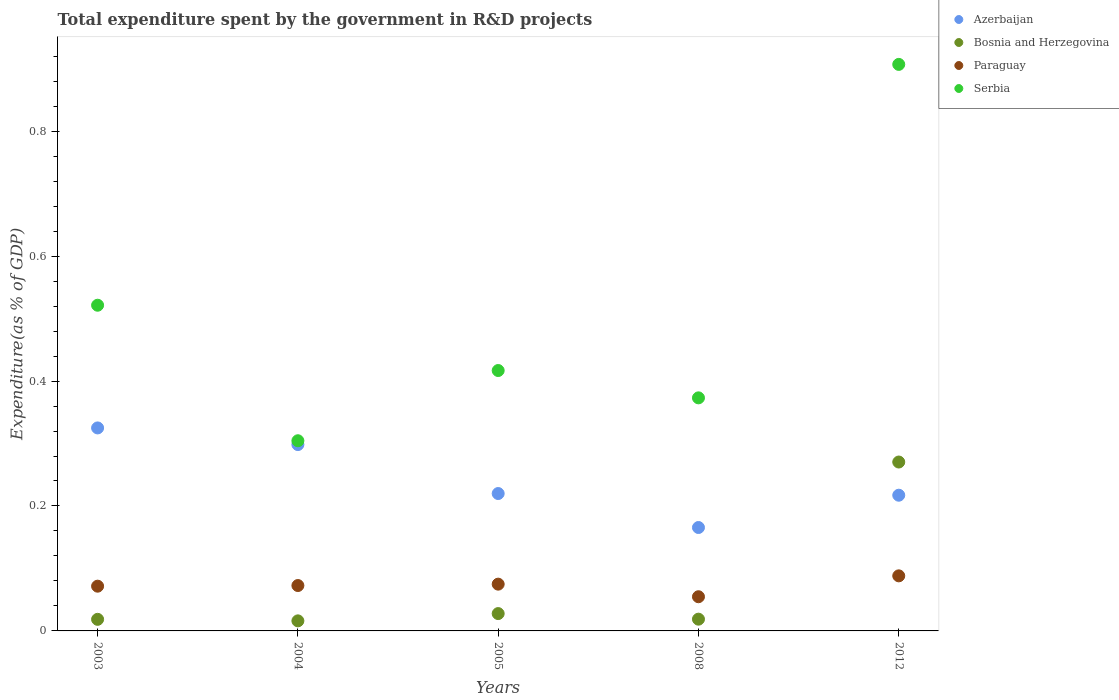How many different coloured dotlines are there?
Offer a terse response. 4. Is the number of dotlines equal to the number of legend labels?
Give a very brief answer. Yes. What is the total expenditure spent by the government in R&D projects in Serbia in 2008?
Give a very brief answer. 0.37. Across all years, what is the maximum total expenditure spent by the government in R&D projects in Paraguay?
Your answer should be very brief. 0.09. Across all years, what is the minimum total expenditure spent by the government in R&D projects in Bosnia and Herzegovina?
Keep it short and to the point. 0.02. In which year was the total expenditure spent by the government in R&D projects in Paraguay maximum?
Keep it short and to the point. 2012. In which year was the total expenditure spent by the government in R&D projects in Serbia minimum?
Provide a short and direct response. 2004. What is the total total expenditure spent by the government in R&D projects in Serbia in the graph?
Make the answer very short. 2.52. What is the difference between the total expenditure spent by the government in R&D projects in Serbia in 2004 and that in 2012?
Offer a very short reply. -0.6. What is the difference between the total expenditure spent by the government in R&D projects in Bosnia and Herzegovina in 2004 and the total expenditure spent by the government in R&D projects in Serbia in 2003?
Your response must be concise. -0.51. What is the average total expenditure spent by the government in R&D projects in Paraguay per year?
Provide a short and direct response. 0.07. In the year 2008, what is the difference between the total expenditure spent by the government in R&D projects in Serbia and total expenditure spent by the government in R&D projects in Paraguay?
Provide a short and direct response. 0.32. What is the ratio of the total expenditure spent by the government in R&D projects in Serbia in 2004 to that in 2008?
Provide a succinct answer. 0.82. Is the total expenditure spent by the government in R&D projects in Paraguay in 2003 less than that in 2008?
Provide a succinct answer. No. What is the difference between the highest and the second highest total expenditure spent by the government in R&D projects in Paraguay?
Offer a very short reply. 0.01. What is the difference between the highest and the lowest total expenditure spent by the government in R&D projects in Serbia?
Your response must be concise. 0.6. In how many years, is the total expenditure spent by the government in R&D projects in Serbia greater than the average total expenditure spent by the government in R&D projects in Serbia taken over all years?
Give a very brief answer. 2. Is it the case that in every year, the sum of the total expenditure spent by the government in R&D projects in Bosnia and Herzegovina and total expenditure spent by the government in R&D projects in Paraguay  is greater than the sum of total expenditure spent by the government in R&D projects in Azerbaijan and total expenditure spent by the government in R&D projects in Serbia?
Your answer should be compact. No. Is it the case that in every year, the sum of the total expenditure spent by the government in R&D projects in Azerbaijan and total expenditure spent by the government in R&D projects in Serbia  is greater than the total expenditure spent by the government in R&D projects in Bosnia and Herzegovina?
Provide a short and direct response. Yes. How many dotlines are there?
Give a very brief answer. 4. How many legend labels are there?
Provide a succinct answer. 4. What is the title of the graph?
Make the answer very short. Total expenditure spent by the government in R&D projects. What is the label or title of the Y-axis?
Your answer should be compact. Expenditure(as % of GDP). What is the Expenditure(as % of GDP) of Azerbaijan in 2003?
Your response must be concise. 0.32. What is the Expenditure(as % of GDP) in Bosnia and Herzegovina in 2003?
Your answer should be very brief. 0.02. What is the Expenditure(as % of GDP) in Paraguay in 2003?
Your answer should be compact. 0.07. What is the Expenditure(as % of GDP) of Serbia in 2003?
Give a very brief answer. 0.52. What is the Expenditure(as % of GDP) of Azerbaijan in 2004?
Make the answer very short. 0.3. What is the Expenditure(as % of GDP) of Bosnia and Herzegovina in 2004?
Offer a terse response. 0.02. What is the Expenditure(as % of GDP) of Paraguay in 2004?
Offer a terse response. 0.07. What is the Expenditure(as % of GDP) in Serbia in 2004?
Offer a terse response. 0.3. What is the Expenditure(as % of GDP) in Azerbaijan in 2005?
Your answer should be compact. 0.22. What is the Expenditure(as % of GDP) in Bosnia and Herzegovina in 2005?
Your answer should be compact. 0.03. What is the Expenditure(as % of GDP) in Paraguay in 2005?
Your answer should be very brief. 0.07. What is the Expenditure(as % of GDP) of Serbia in 2005?
Offer a very short reply. 0.42. What is the Expenditure(as % of GDP) in Azerbaijan in 2008?
Offer a very short reply. 0.17. What is the Expenditure(as % of GDP) in Bosnia and Herzegovina in 2008?
Provide a succinct answer. 0.02. What is the Expenditure(as % of GDP) of Paraguay in 2008?
Provide a succinct answer. 0.05. What is the Expenditure(as % of GDP) of Serbia in 2008?
Make the answer very short. 0.37. What is the Expenditure(as % of GDP) in Azerbaijan in 2012?
Offer a very short reply. 0.22. What is the Expenditure(as % of GDP) in Bosnia and Herzegovina in 2012?
Your answer should be compact. 0.27. What is the Expenditure(as % of GDP) of Paraguay in 2012?
Make the answer very short. 0.09. What is the Expenditure(as % of GDP) of Serbia in 2012?
Offer a very short reply. 0.91. Across all years, what is the maximum Expenditure(as % of GDP) in Azerbaijan?
Offer a terse response. 0.32. Across all years, what is the maximum Expenditure(as % of GDP) of Bosnia and Herzegovina?
Provide a succinct answer. 0.27. Across all years, what is the maximum Expenditure(as % of GDP) in Paraguay?
Provide a succinct answer. 0.09. Across all years, what is the maximum Expenditure(as % of GDP) of Serbia?
Give a very brief answer. 0.91. Across all years, what is the minimum Expenditure(as % of GDP) of Azerbaijan?
Ensure brevity in your answer.  0.17. Across all years, what is the minimum Expenditure(as % of GDP) in Bosnia and Herzegovina?
Ensure brevity in your answer.  0.02. Across all years, what is the minimum Expenditure(as % of GDP) in Paraguay?
Your answer should be compact. 0.05. Across all years, what is the minimum Expenditure(as % of GDP) of Serbia?
Your response must be concise. 0.3. What is the total Expenditure(as % of GDP) in Azerbaijan in the graph?
Your answer should be compact. 1.23. What is the total Expenditure(as % of GDP) of Bosnia and Herzegovina in the graph?
Offer a terse response. 0.35. What is the total Expenditure(as % of GDP) in Paraguay in the graph?
Provide a short and direct response. 0.36. What is the total Expenditure(as % of GDP) of Serbia in the graph?
Your answer should be compact. 2.52. What is the difference between the Expenditure(as % of GDP) of Azerbaijan in 2003 and that in 2004?
Provide a succinct answer. 0.03. What is the difference between the Expenditure(as % of GDP) of Bosnia and Herzegovina in 2003 and that in 2004?
Give a very brief answer. 0. What is the difference between the Expenditure(as % of GDP) of Paraguay in 2003 and that in 2004?
Ensure brevity in your answer.  -0. What is the difference between the Expenditure(as % of GDP) of Serbia in 2003 and that in 2004?
Give a very brief answer. 0.22. What is the difference between the Expenditure(as % of GDP) of Azerbaijan in 2003 and that in 2005?
Ensure brevity in your answer.  0.1. What is the difference between the Expenditure(as % of GDP) of Bosnia and Herzegovina in 2003 and that in 2005?
Your answer should be very brief. -0.01. What is the difference between the Expenditure(as % of GDP) of Paraguay in 2003 and that in 2005?
Offer a terse response. -0. What is the difference between the Expenditure(as % of GDP) in Serbia in 2003 and that in 2005?
Make the answer very short. 0.1. What is the difference between the Expenditure(as % of GDP) in Azerbaijan in 2003 and that in 2008?
Give a very brief answer. 0.16. What is the difference between the Expenditure(as % of GDP) of Bosnia and Herzegovina in 2003 and that in 2008?
Give a very brief answer. -0. What is the difference between the Expenditure(as % of GDP) in Paraguay in 2003 and that in 2008?
Keep it short and to the point. 0.02. What is the difference between the Expenditure(as % of GDP) of Serbia in 2003 and that in 2008?
Offer a terse response. 0.15. What is the difference between the Expenditure(as % of GDP) of Azerbaijan in 2003 and that in 2012?
Your response must be concise. 0.11. What is the difference between the Expenditure(as % of GDP) of Bosnia and Herzegovina in 2003 and that in 2012?
Give a very brief answer. -0.25. What is the difference between the Expenditure(as % of GDP) in Paraguay in 2003 and that in 2012?
Your answer should be compact. -0.02. What is the difference between the Expenditure(as % of GDP) in Serbia in 2003 and that in 2012?
Give a very brief answer. -0.39. What is the difference between the Expenditure(as % of GDP) in Azerbaijan in 2004 and that in 2005?
Give a very brief answer. 0.08. What is the difference between the Expenditure(as % of GDP) of Bosnia and Herzegovina in 2004 and that in 2005?
Your answer should be very brief. -0.01. What is the difference between the Expenditure(as % of GDP) in Paraguay in 2004 and that in 2005?
Your response must be concise. -0. What is the difference between the Expenditure(as % of GDP) in Serbia in 2004 and that in 2005?
Your answer should be compact. -0.11. What is the difference between the Expenditure(as % of GDP) in Azerbaijan in 2004 and that in 2008?
Offer a terse response. 0.13. What is the difference between the Expenditure(as % of GDP) in Bosnia and Herzegovina in 2004 and that in 2008?
Make the answer very short. -0. What is the difference between the Expenditure(as % of GDP) in Paraguay in 2004 and that in 2008?
Provide a succinct answer. 0.02. What is the difference between the Expenditure(as % of GDP) of Serbia in 2004 and that in 2008?
Offer a very short reply. -0.07. What is the difference between the Expenditure(as % of GDP) of Azerbaijan in 2004 and that in 2012?
Offer a very short reply. 0.08. What is the difference between the Expenditure(as % of GDP) in Bosnia and Herzegovina in 2004 and that in 2012?
Ensure brevity in your answer.  -0.25. What is the difference between the Expenditure(as % of GDP) of Paraguay in 2004 and that in 2012?
Provide a short and direct response. -0.02. What is the difference between the Expenditure(as % of GDP) in Serbia in 2004 and that in 2012?
Provide a succinct answer. -0.6. What is the difference between the Expenditure(as % of GDP) in Azerbaijan in 2005 and that in 2008?
Keep it short and to the point. 0.05. What is the difference between the Expenditure(as % of GDP) of Bosnia and Herzegovina in 2005 and that in 2008?
Your response must be concise. 0.01. What is the difference between the Expenditure(as % of GDP) in Paraguay in 2005 and that in 2008?
Your answer should be compact. 0.02. What is the difference between the Expenditure(as % of GDP) of Serbia in 2005 and that in 2008?
Provide a succinct answer. 0.04. What is the difference between the Expenditure(as % of GDP) in Azerbaijan in 2005 and that in 2012?
Give a very brief answer. 0. What is the difference between the Expenditure(as % of GDP) of Bosnia and Herzegovina in 2005 and that in 2012?
Make the answer very short. -0.24. What is the difference between the Expenditure(as % of GDP) in Paraguay in 2005 and that in 2012?
Your response must be concise. -0.01. What is the difference between the Expenditure(as % of GDP) in Serbia in 2005 and that in 2012?
Offer a very short reply. -0.49. What is the difference between the Expenditure(as % of GDP) in Azerbaijan in 2008 and that in 2012?
Your response must be concise. -0.05. What is the difference between the Expenditure(as % of GDP) in Bosnia and Herzegovina in 2008 and that in 2012?
Your answer should be compact. -0.25. What is the difference between the Expenditure(as % of GDP) of Paraguay in 2008 and that in 2012?
Provide a short and direct response. -0.03. What is the difference between the Expenditure(as % of GDP) of Serbia in 2008 and that in 2012?
Your answer should be very brief. -0.53. What is the difference between the Expenditure(as % of GDP) in Azerbaijan in 2003 and the Expenditure(as % of GDP) in Bosnia and Herzegovina in 2004?
Make the answer very short. 0.31. What is the difference between the Expenditure(as % of GDP) of Azerbaijan in 2003 and the Expenditure(as % of GDP) of Paraguay in 2004?
Ensure brevity in your answer.  0.25. What is the difference between the Expenditure(as % of GDP) of Azerbaijan in 2003 and the Expenditure(as % of GDP) of Serbia in 2004?
Give a very brief answer. 0.02. What is the difference between the Expenditure(as % of GDP) in Bosnia and Herzegovina in 2003 and the Expenditure(as % of GDP) in Paraguay in 2004?
Keep it short and to the point. -0.05. What is the difference between the Expenditure(as % of GDP) in Bosnia and Herzegovina in 2003 and the Expenditure(as % of GDP) in Serbia in 2004?
Provide a succinct answer. -0.29. What is the difference between the Expenditure(as % of GDP) of Paraguay in 2003 and the Expenditure(as % of GDP) of Serbia in 2004?
Your response must be concise. -0.23. What is the difference between the Expenditure(as % of GDP) of Azerbaijan in 2003 and the Expenditure(as % of GDP) of Bosnia and Herzegovina in 2005?
Give a very brief answer. 0.3. What is the difference between the Expenditure(as % of GDP) of Azerbaijan in 2003 and the Expenditure(as % of GDP) of Paraguay in 2005?
Keep it short and to the point. 0.25. What is the difference between the Expenditure(as % of GDP) of Azerbaijan in 2003 and the Expenditure(as % of GDP) of Serbia in 2005?
Provide a succinct answer. -0.09. What is the difference between the Expenditure(as % of GDP) in Bosnia and Herzegovina in 2003 and the Expenditure(as % of GDP) in Paraguay in 2005?
Keep it short and to the point. -0.06. What is the difference between the Expenditure(as % of GDP) of Bosnia and Herzegovina in 2003 and the Expenditure(as % of GDP) of Serbia in 2005?
Your answer should be very brief. -0.4. What is the difference between the Expenditure(as % of GDP) of Paraguay in 2003 and the Expenditure(as % of GDP) of Serbia in 2005?
Your answer should be compact. -0.35. What is the difference between the Expenditure(as % of GDP) in Azerbaijan in 2003 and the Expenditure(as % of GDP) in Bosnia and Herzegovina in 2008?
Keep it short and to the point. 0.31. What is the difference between the Expenditure(as % of GDP) in Azerbaijan in 2003 and the Expenditure(as % of GDP) in Paraguay in 2008?
Your answer should be compact. 0.27. What is the difference between the Expenditure(as % of GDP) in Azerbaijan in 2003 and the Expenditure(as % of GDP) in Serbia in 2008?
Give a very brief answer. -0.05. What is the difference between the Expenditure(as % of GDP) in Bosnia and Herzegovina in 2003 and the Expenditure(as % of GDP) in Paraguay in 2008?
Offer a very short reply. -0.04. What is the difference between the Expenditure(as % of GDP) in Bosnia and Herzegovina in 2003 and the Expenditure(as % of GDP) in Serbia in 2008?
Your answer should be very brief. -0.35. What is the difference between the Expenditure(as % of GDP) of Paraguay in 2003 and the Expenditure(as % of GDP) of Serbia in 2008?
Offer a very short reply. -0.3. What is the difference between the Expenditure(as % of GDP) of Azerbaijan in 2003 and the Expenditure(as % of GDP) of Bosnia and Herzegovina in 2012?
Offer a very short reply. 0.05. What is the difference between the Expenditure(as % of GDP) in Azerbaijan in 2003 and the Expenditure(as % of GDP) in Paraguay in 2012?
Your answer should be very brief. 0.24. What is the difference between the Expenditure(as % of GDP) in Azerbaijan in 2003 and the Expenditure(as % of GDP) in Serbia in 2012?
Keep it short and to the point. -0.58. What is the difference between the Expenditure(as % of GDP) of Bosnia and Herzegovina in 2003 and the Expenditure(as % of GDP) of Paraguay in 2012?
Offer a very short reply. -0.07. What is the difference between the Expenditure(as % of GDP) of Bosnia and Herzegovina in 2003 and the Expenditure(as % of GDP) of Serbia in 2012?
Give a very brief answer. -0.89. What is the difference between the Expenditure(as % of GDP) in Paraguay in 2003 and the Expenditure(as % of GDP) in Serbia in 2012?
Provide a short and direct response. -0.84. What is the difference between the Expenditure(as % of GDP) in Azerbaijan in 2004 and the Expenditure(as % of GDP) in Bosnia and Herzegovina in 2005?
Your answer should be compact. 0.27. What is the difference between the Expenditure(as % of GDP) of Azerbaijan in 2004 and the Expenditure(as % of GDP) of Paraguay in 2005?
Offer a terse response. 0.22. What is the difference between the Expenditure(as % of GDP) of Azerbaijan in 2004 and the Expenditure(as % of GDP) of Serbia in 2005?
Your answer should be very brief. -0.12. What is the difference between the Expenditure(as % of GDP) of Bosnia and Herzegovina in 2004 and the Expenditure(as % of GDP) of Paraguay in 2005?
Give a very brief answer. -0.06. What is the difference between the Expenditure(as % of GDP) of Bosnia and Herzegovina in 2004 and the Expenditure(as % of GDP) of Serbia in 2005?
Provide a short and direct response. -0.4. What is the difference between the Expenditure(as % of GDP) of Paraguay in 2004 and the Expenditure(as % of GDP) of Serbia in 2005?
Your response must be concise. -0.34. What is the difference between the Expenditure(as % of GDP) in Azerbaijan in 2004 and the Expenditure(as % of GDP) in Bosnia and Herzegovina in 2008?
Provide a short and direct response. 0.28. What is the difference between the Expenditure(as % of GDP) in Azerbaijan in 2004 and the Expenditure(as % of GDP) in Paraguay in 2008?
Offer a terse response. 0.24. What is the difference between the Expenditure(as % of GDP) in Azerbaijan in 2004 and the Expenditure(as % of GDP) in Serbia in 2008?
Make the answer very short. -0.07. What is the difference between the Expenditure(as % of GDP) of Bosnia and Herzegovina in 2004 and the Expenditure(as % of GDP) of Paraguay in 2008?
Provide a short and direct response. -0.04. What is the difference between the Expenditure(as % of GDP) of Bosnia and Herzegovina in 2004 and the Expenditure(as % of GDP) of Serbia in 2008?
Your answer should be very brief. -0.36. What is the difference between the Expenditure(as % of GDP) of Paraguay in 2004 and the Expenditure(as % of GDP) of Serbia in 2008?
Keep it short and to the point. -0.3. What is the difference between the Expenditure(as % of GDP) in Azerbaijan in 2004 and the Expenditure(as % of GDP) in Bosnia and Herzegovina in 2012?
Your response must be concise. 0.03. What is the difference between the Expenditure(as % of GDP) of Azerbaijan in 2004 and the Expenditure(as % of GDP) of Paraguay in 2012?
Keep it short and to the point. 0.21. What is the difference between the Expenditure(as % of GDP) of Azerbaijan in 2004 and the Expenditure(as % of GDP) of Serbia in 2012?
Give a very brief answer. -0.61. What is the difference between the Expenditure(as % of GDP) in Bosnia and Herzegovina in 2004 and the Expenditure(as % of GDP) in Paraguay in 2012?
Your answer should be compact. -0.07. What is the difference between the Expenditure(as % of GDP) in Bosnia and Herzegovina in 2004 and the Expenditure(as % of GDP) in Serbia in 2012?
Provide a succinct answer. -0.89. What is the difference between the Expenditure(as % of GDP) in Paraguay in 2004 and the Expenditure(as % of GDP) in Serbia in 2012?
Your answer should be compact. -0.83. What is the difference between the Expenditure(as % of GDP) of Azerbaijan in 2005 and the Expenditure(as % of GDP) of Bosnia and Herzegovina in 2008?
Make the answer very short. 0.2. What is the difference between the Expenditure(as % of GDP) of Azerbaijan in 2005 and the Expenditure(as % of GDP) of Paraguay in 2008?
Provide a succinct answer. 0.17. What is the difference between the Expenditure(as % of GDP) of Azerbaijan in 2005 and the Expenditure(as % of GDP) of Serbia in 2008?
Keep it short and to the point. -0.15. What is the difference between the Expenditure(as % of GDP) in Bosnia and Herzegovina in 2005 and the Expenditure(as % of GDP) in Paraguay in 2008?
Your response must be concise. -0.03. What is the difference between the Expenditure(as % of GDP) in Bosnia and Herzegovina in 2005 and the Expenditure(as % of GDP) in Serbia in 2008?
Your answer should be very brief. -0.35. What is the difference between the Expenditure(as % of GDP) of Paraguay in 2005 and the Expenditure(as % of GDP) of Serbia in 2008?
Offer a terse response. -0.3. What is the difference between the Expenditure(as % of GDP) of Azerbaijan in 2005 and the Expenditure(as % of GDP) of Bosnia and Herzegovina in 2012?
Your answer should be very brief. -0.05. What is the difference between the Expenditure(as % of GDP) of Azerbaijan in 2005 and the Expenditure(as % of GDP) of Paraguay in 2012?
Your answer should be compact. 0.13. What is the difference between the Expenditure(as % of GDP) of Azerbaijan in 2005 and the Expenditure(as % of GDP) of Serbia in 2012?
Offer a very short reply. -0.69. What is the difference between the Expenditure(as % of GDP) of Bosnia and Herzegovina in 2005 and the Expenditure(as % of GDP) of Paraguay in 2012?
Offer a very short reply. -0.06. What is the difference between the Expenditure(as % of GDP) in Bosnia and Herzegovina in 2005 and the Expenditure(as % of GDP) in Serbia in 2012?
Ensure brevity in your answer.  -0.88. What is the difference between the Expenditure(as % of GDP) of Paraguay in 2005 and the Expenditure(as % of GDP) of Serbia in 2012?
Your answer should be very brief. -0.83. What is the difference between the Expenditure(as % of GDP) in Azerbaijan in 2008 and the Expenditure(as % of GDP) in Bosnia and Herzegovina in 2012?
Your response must be concise. -0.1. What is the difference between the Expenditure(as % of GDP) in Azerbaijan in 2008 and the Expenditure(as % of GDP) in Paraguay in 2012?
Offer a terse response. 0.08. What is the difference between the Expenditure(as % of GDP) of Azerbaijan in 2008 and the Expenditure(as % of GDP) of Serbia in 2012?
Give a very brief answer. -0.74. What is the difference between the Expenditure(as % of GDP) of Bosnia and Herzegovina in 2008 and the Expenditure(as % of GDP) of Paraguay in 2012?
Provide a succinct answer. -0.07. What is the difference between the Expenditure(as % of GDP) of Bosnia and Herzegovina in 2008 and the Expenditure(as % of GDP) of Serbia in 2012?
Your answer should be compact. -0.89. What is the difference between the Expenditure(as % of GDP) of Paraguay in 2008 and the Expenditure(as % of GDP) of Serbia in 2012?
Ensure brevity in your answer.  -0.85. What is the average Expenditure(as % of GDP) in Azerbaijan per year?
Give a very brief answer. 0.25. What is the average Expenditure(as % of GDP) in Bosnia and Herzegovina per year?
Your answer should be very brief. 0.07. What is the average Expenditure(as % of GDP) in Paraguay per year?
Ensure brevity in your answer.  0.07. What is the average Expenditure(as % of GDP) of Serbia per year?
Make the answer very short. 0.5. In the year 2003, what is the difference between the Expenditure(as % of GDP) in Azerbaijan and Expenditure(as % of GDP) in Bosnia and Herzegovina?
Keep it short and to the point. 0.31. In the year 2003, what is the difference between the Expenditure(as % of GDP) of Azerbaijan and Expenditure(as % of GDP) of Paraguay?
Your response must be concise. 0.25. In the year 2003, what is the difference between the Expenditure(as % of GDP) of Azerbaijan and Expenditure(as % of GDP) of Serbia?
Provide a short and direct response. -0.2. In the year 2003, what is the difference between the Expenditure(as % of GDP) in Bosnia and Herzegovina and Expenditure(as % of GDP) in Paraguay?
Offer a terse response. -0.05. In the year 2003, what is the difference between the Expenditure(as % of GDP) in Bosnia and Herzegovina and Expenditure(as % of GDP) in Serbia?
Offer a very short reply. -0.5. In the year 2003, what is the difference between the Expenditure(as % of GDP) of Paraguay and Expenditure(as % of GDP) of Serbia?
Keep it short and to the point. -0.45. In the year 2004, what is the difference between the Expenditure(as % of GDP) of Azerbaijan and Expenditure(as % of GDP) of Bosnia and Herzegovina?
Keep it short and to the point. 0.28. In the year 2004, what is the difference between the Expenditure(as % of GDP) of Azerbaijan and Expenditure(as % of GDP) of Paraguay?
Give a very brief answer. 0.23. In the year 2004, what is the difference between the Expenditure(as % of GDP) of Azerbaijan and Expenditure(as % of GDP) of Serbia?
Ensure brevity in your answer.  -0.01. In the year 2004, what is the difference between the Expenditure(as % of GDP) in Bosnia and Herzegovina and Expenditure(as % of GDP) in Paraguay?
Give a very brief answer. -0.06. In the year 2004, what is the difference between the Expenditure(as % of GDP) in Bosnia and Herzegovina and Expenditure(as % of GDP) in Serbia?
Keep it short and to the point. -0.29. In the year 2004, what is the difference between the Expenditure(as % of GDP) in Paraguay and Expenditure(as % of GDP) in Serbia?
Provide a succinct answer. -0.23. In the year 2005, what is the difference between the Expenditure(as % of GDP) of Azerbaijan and Expenditure(as % of GDP) of Bosnia and Herzegovina?
Provide a succinct answer. 0.19. In the year 2005, what is the difference between the Expenditure(as % of GDP) in Azerbaijan and Expenditure(as % of GDP) in Paraguay?
Your answer should be very brief. 0.15. In the year 2005, what is the difference between the Expenditure(as % of GDP) of Azerbaijan and Expenditure(as % of GDP) of Serbia?
Offer a very short reply. -0.2. In the year 2005, what is the difference between the Expenditure(as % of GDP) of Bosnia and Herzegovina and Expenditure(as % of GDP) of Paraguay?
Ensure brevity in your answer.  -0.05. In the year 2005, what is the difference between the Expenditure(as % of GDP) in Bosnia and Herzegovina and Expenditure(as % of GDP) in Serbia?
Ensure brevity in your answer.  -0.39. In the year 2005, what is the difference between the Expenditure(as % of GDP) in Paraguay and Expenditure(as % of GDP) in Serbia?
Keep it short and to the point. -0.34. In the year 2008, what is the difference between the Expenditure(as % of GDP) of Azerbaijan and Expenditure(as % of GDP) of Bosnia and Herzegovina?
Provide a short and direct response. 0.15. In the year 2008, what is the difference between the Expenditure(as % of GDP) in Azerbaijan and Expenditure(as % of GDP) in Paraguay?
Keep it short and to the point. 0.11. In the year 2008, what is the difference between the Expenditure(as % of GDP) of Azerbaijan and Expenditure(as % of GDP) of Serbia?
Provide a succinct answer. -0.21. In the year 2008, what is the difference between the Expenditure(as % of GDP) in Bosnia and Herzegovina and Expenditure(as % of GDP) in Paraguay?
Provide a succinct answer. -0.04. In the year 2008, what is the difference between the Expenditure(as % of GDP) of Bosnia and Herzegovina and Expenditure(as % of GDP) of Serbia?
Your response must be concise. -0.35. In the year 2008, what is the difference between the Expenditure(as % of GDP) of Paraguay and Expenditure(as % of GDP) of Serbia?
Keep it short and to the point. -0.32. In the year 2012, what is the difference between the Expenditure(as % of GDP) in Azerbaijan and Expenditure(as % of GDP) in Bosnia and Herzegovina?
Your answer should be very brief. -0.05. In the year 2012, what is the difference between the Expenditure(as % of GDP) of Azerbaijan and Expenditure(as % of GDP) of Paraguay?
Keep it short and to the point. 0.13. In the year 2012, what is the difference between the Expenditure(as % of GDP) in Azerbaijan and Expenditure(as % of GDP) in Serbia?
Your answer should be very brief. -0.69. In the year 2012, what is the difference between the Expenditure(as % of GDP) of Bosnia and Herzegovina and Expenditure(as % of GDP) of Paraguay?
Give a very brief answer. 0.18. In the year 2012, what is the difference between the Expenditure(as % of GDP) of Bosnia and Herzegovina and Expenditure(as % of GDP) of Serbia?
Make the answer very short. -0.64. In the year 2012, what is the difference between the Expenditure(as % of GDP) of Paraguay and Expenditure(as % of GDP) of Serbia?
Provide a succinct answer. -0.82. What is the ratio of the Expenditure(as % of GDP) of Azerbaijan in 2003 to that in 2004?
Offer a terse response. 1.09. What is the ratio of the Expenditure(as % of GDP) of Bosnia and Herzegovina in 2003 to that in 2004?
Offer a terse response. 1.15. What is the ratio of the Expenditure(as % of GDP) in Paraguay in 2003 to that in 2004?
Provide a succinct answer. 0.99. What is the ratio of the Expenditure(as % of GDP) in Serbia in 2003 to that in 2004?
Keep it short and to the point. 1.71. What is the ratio of the Expenditure(as % of GDP) of Azerbaijan in 2003 to that in 2005?
Your response must be concise. 1.48. What is the ratio of the Expenditure(as % of GDP) of Bosnia and Herzegovina in 2003 to that in 2005?
Make the answer very short. 0.67. What is the ratio of the Expenditure(as % of GDP) of Paraguay in 2003 to that in 2005?
Give a very brief answer. 0.96. What is the ratio of the Expenditure(as % of GDP) of Serbia in 2003 to that in 2005?
Keep it short and to the point. 1.25. What is the ratio of the Expenditure(as % of GDP) in Azerbaijan in 2003 to that in 2008?
Your answer should be compact. 1.96. What is the ratio of the Expenditure(as % of GDP) of Bosnia and Herzegovina in 2003 to that in 2008?
Your answer should be compact. 0.99. What is the ratio of the Expenditure(as % of GDP) of Paraguay in 2003 to that in 2008?
Offer a terse response. 1.31. What is the ratio of the Expenditure(as % of GDP) of Serbia in 2003 to that in 2008?
Provide a succinct answer. 1.4. What is the ratio of the Expenditure(as % of GDP) of Azerbaijan in 2003 to that in 2012?
Make the answer very short. 1.5. What is the ratio of the Expenditure(as % of GDP) of Bosnia and Herzegovina in 2003 to that in 2012?
Provide a succinct answer. 0.07. What is the ratio of the Expenditure(as % of GDP) of Paraguay in 2003 to that in 2012?
Give a very brief answer. 0.81. What is the ratio of the Expenditure(as % of GDP) in Serbia in 2003 to that in 2012?
Ensure brevity in your answer.  0.57. What is the ratio of the Expenditure(as % of GDP) of Azerbaijan in 2004 to that in 2005?
Provide a short and direct response. 1.36. What is the ratio of the Expenditure(as % of GDP) of Bosnia and Herzegovina in 2004 to that in 2005?
Provide a short and direct response. 0.58. What is the ratio of the Expenditure(as % of GDP) in Paraguay in 2004 to that in 2005?
Your answer should be compact. 0.97. What is the ratio of the Expenditure(as % of GDP) in Serbia in 2004 to that in 2005?
Provide a succinct answer. 0.73. What is the ratio of the Expenditure(as % of GDP) in Azerbaijan in 2004 to that in 2008?
Your answer should be very brief. 1.8. What is the ratio of the Expenditure(as % of GDP) of Bosnia and Herzegovina in 2004 to that in 2008?
Your answer should be compact. 0.86. What is the ratio of the Expenditure(as % of GDP) of Paraguay in 2004 to that in 2008?
Ensure brevity in your answer.  1.33. What is the ratio of the Expenditure(as % of GDP) in Serbia in 2004 to that in 2008?
Your response must be concise. 0.82. What is the ratio of the Expenditure(as % of GDP) of Azerbaijan in 2004 to that in 2012?
Your answer should be very brief. 1.37. What is the ratio of the Expenditure(as % of GDP) of Bosnia and Herzegovina in 2004 to that in 2012?
Provide a succinct answer. 0.06. What is the ratio of the Expenditure(as % of GDP) of Paraguay in 2004 to that in 2012?
Ensure brevity in your answer.  0.82. What is the ratio of the Expenditure(as % of GDP) of Serbia in 2004 to that in 2012?
Your answer should be very brief. 0.34. What is the ratio of the Expenditure(as % of GDP) of Azerbaijan in 2005 to that in 2008?
Give a very brief answer. 1.33. What is the ratio of the Expenditure(as % of GDP) of Bosnia and Herzegovina in 2005 to that in 2008?
Provide a short and direct response. 1.48. What is the ratio of the Expenditure(as % of GDP) in Paraguay in 2005 to that in 2008?
Your answer should be compact. 1.37. What is the ratio of the Expenditure(as % of GDP) of Serbia in 2005 to that in 2008?
Your answer should be compact. 1.12. What is the ratio of the Expenditure(as % of GDP) of Azerbaijan in 2005 to that in 2012?
Your answer should be compact. 1.01. What is the ratio of the Expenditure(as % of GDP) of Bosnia and Herzegovina in 2005 to that in 2012?
Give a very brief answer. 0.1. What is the ratio of the Expenditure(as % of GDP) of Paraguay in 2005 to that in 2012?
Provide a short and direct response. 0.85. What is the ratio of the Expenditure(as % of GDP) of Serbia in 2005 to that in 2012?
Offer a terse response. 0.46. What is the ratio of the Expenditure(as % of GDP) in Azerbaijan in 2008 to that in 2012?
Provide a succinct answer. 0.76. What is the ratio of the Expenditure(as % of GDP) in Bosnia and Herzegovina in 2008 to that in 2012?
Your response must be concise. 0.07. What is the ratio of the Expenditure(as % of GDP) of Paraguay in 2008 to that in 2012?
Provide a succinct answer. 0.62. What is the ratio of the Expenditure(as % of GDP) in Serbia in 2008 to that in 2012?
Give a very brief answer. 0.41. What is the difference between the highest and the second highest Expenditure(as % of GDP) of Azerbaijan?
Keep it short and to the point. 0.03. What is the difference between the highest and the second highest Expenditure(as % of GDP) of Bosnia and Herzegovina?
Offer a terse response. 0.24. What is the difference between the highest and the second highest Expenditure(as % of GDP) of Paraguay?
Offer a terse response. 0.01. What is the difference between the highest and the second highest Expenditure(as % of GDP) in Serbia?
Make the answer very short. 0.39. What is the difference between the highest and the lowest Expenditure(as % of GDP) of Azerbaijan?
Your answer should be compact. 0.16. What is the difference between the highest and the lowest Expenditure(as % of GDP) of Bosnia and Herzegovina?
Make the answer very short. 0.25. What is the difference between the highest and the lowest Expenditure(as % of GDP) in Paraguay?
Give a very brief answer. 0.03. What is the difference between the highest and the lowest Expenditure(as % of GDP) of Serbia?
Make the answer very short. 0.6. 